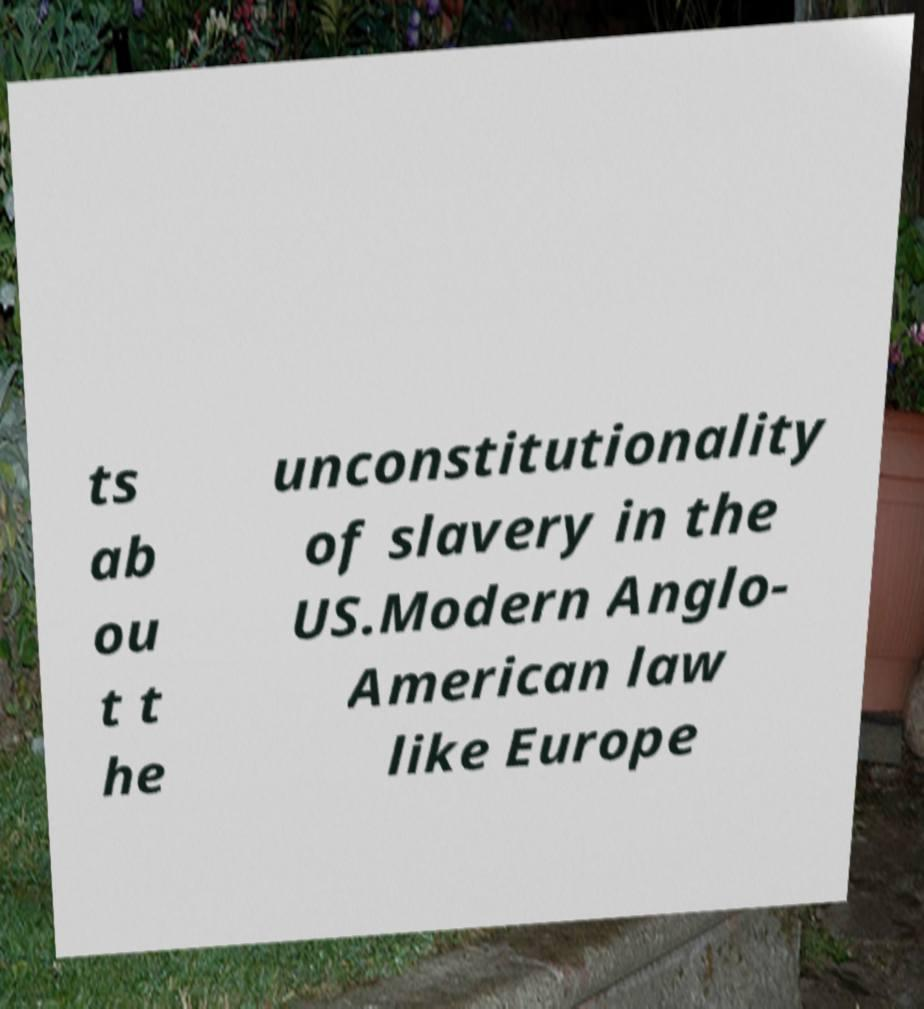Could you assist in decoding the text presented in this image and type it out clearly? ts ab ou t t he unconstitutionality of slavery in the US.Modern Anglo- American law like Europe 